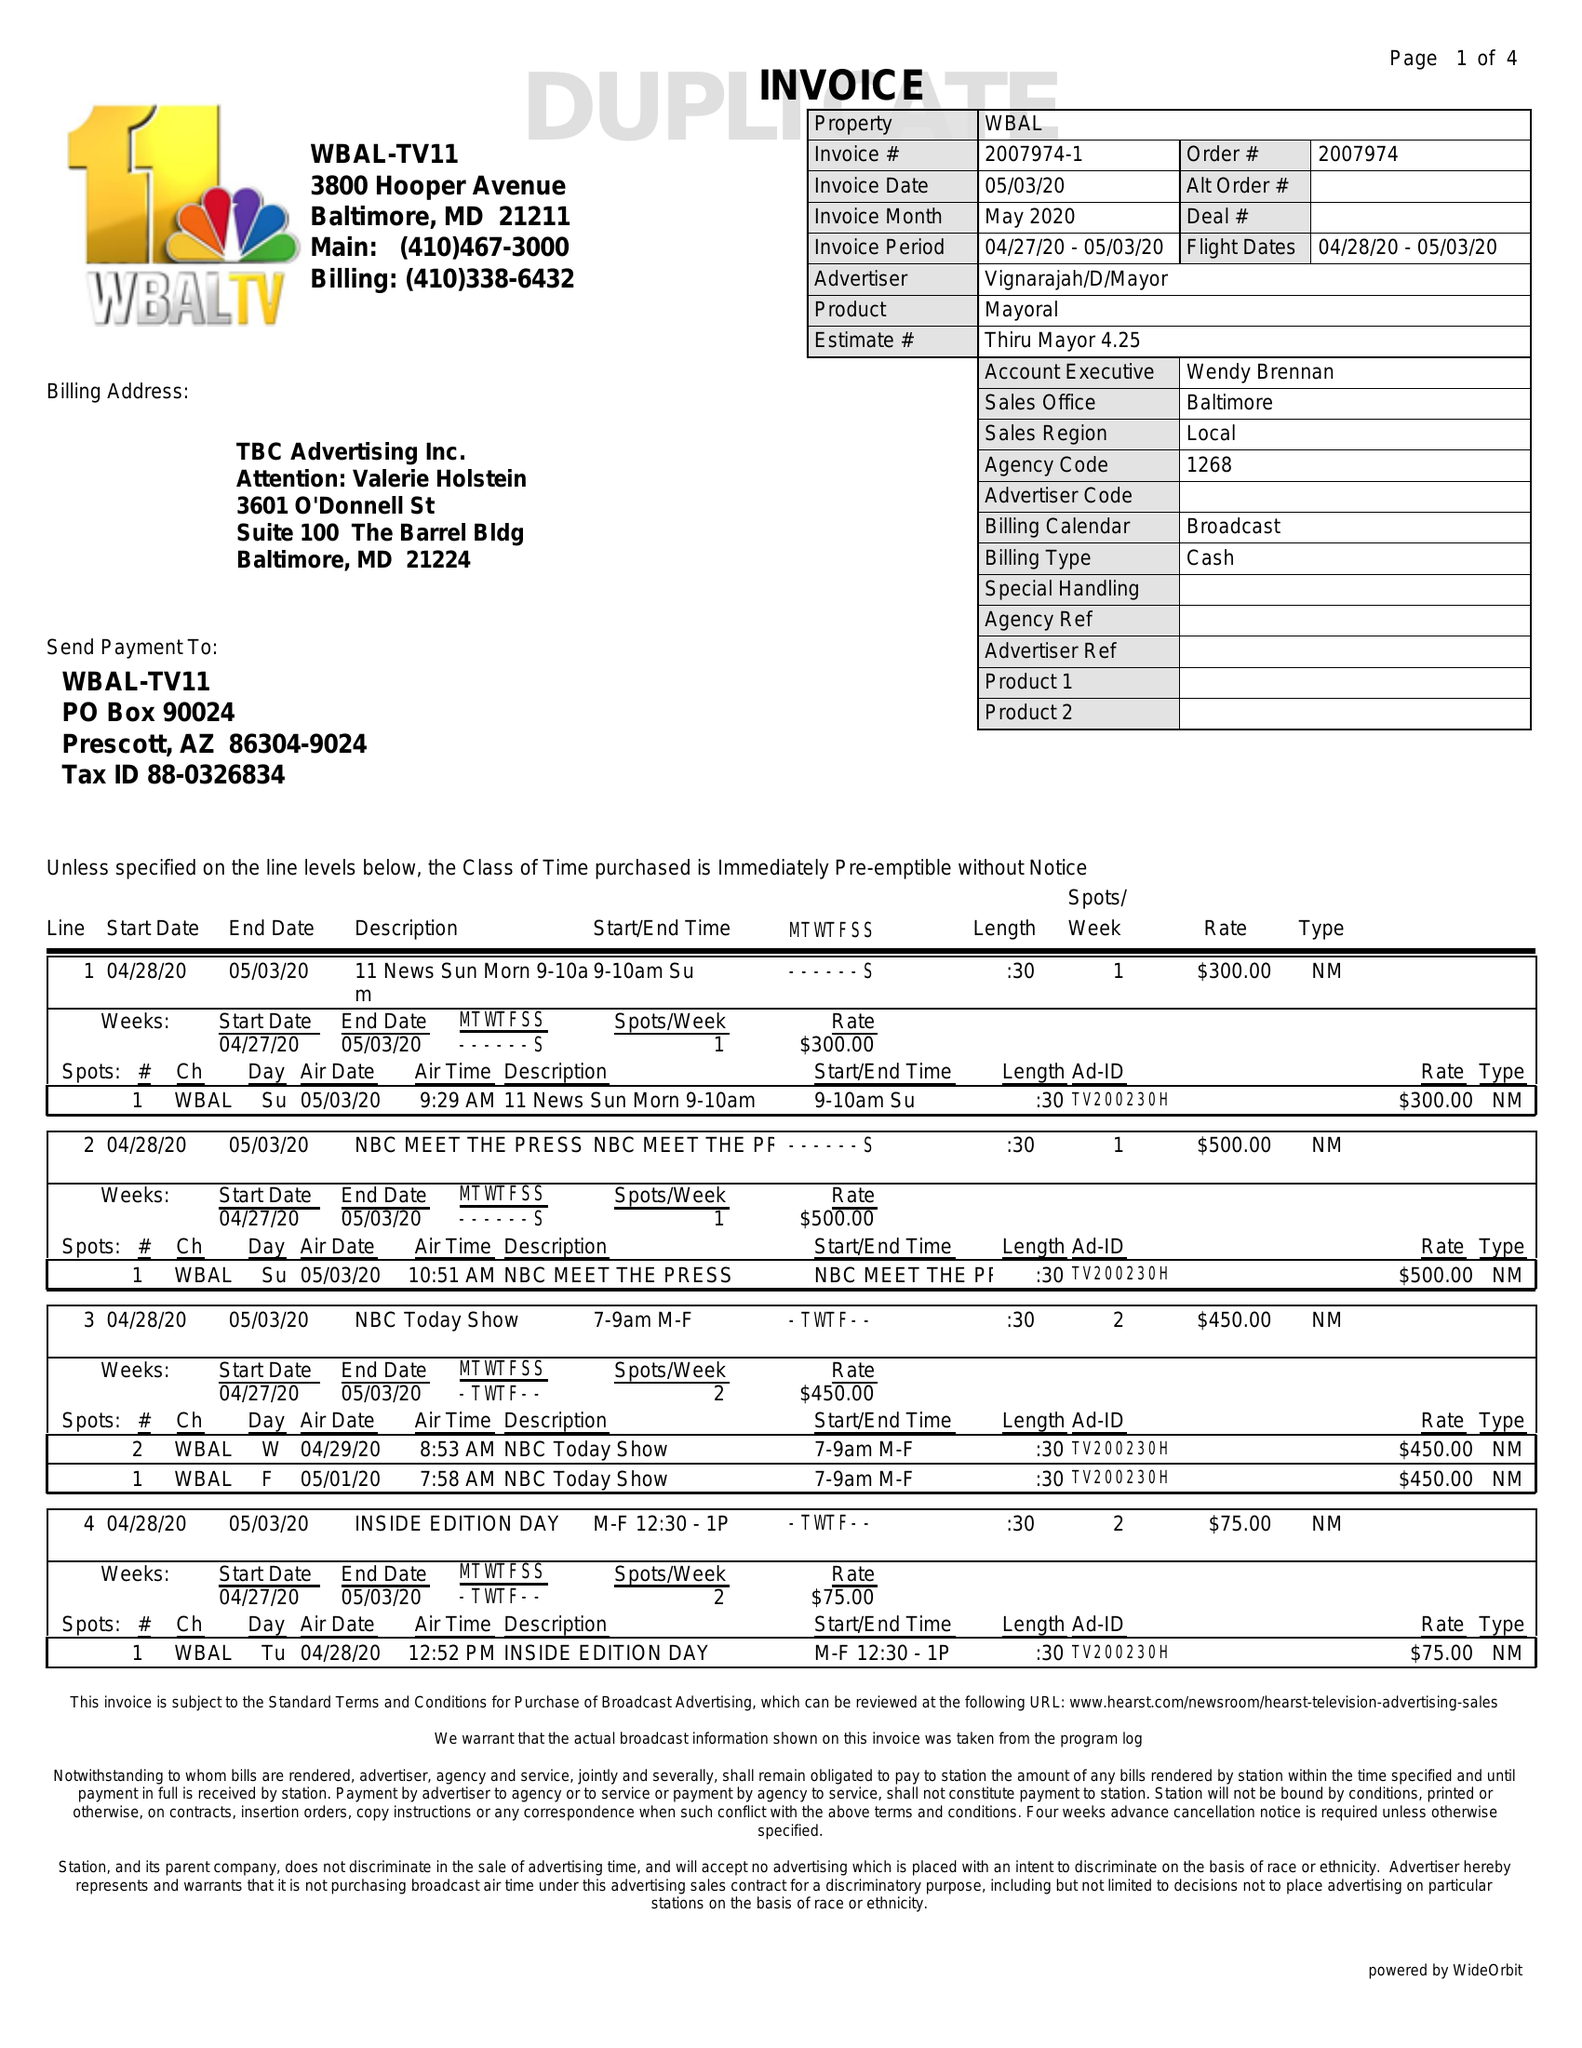What is the value for the flight_from?
Answer the question using a single word or phrase. 04/28/20 